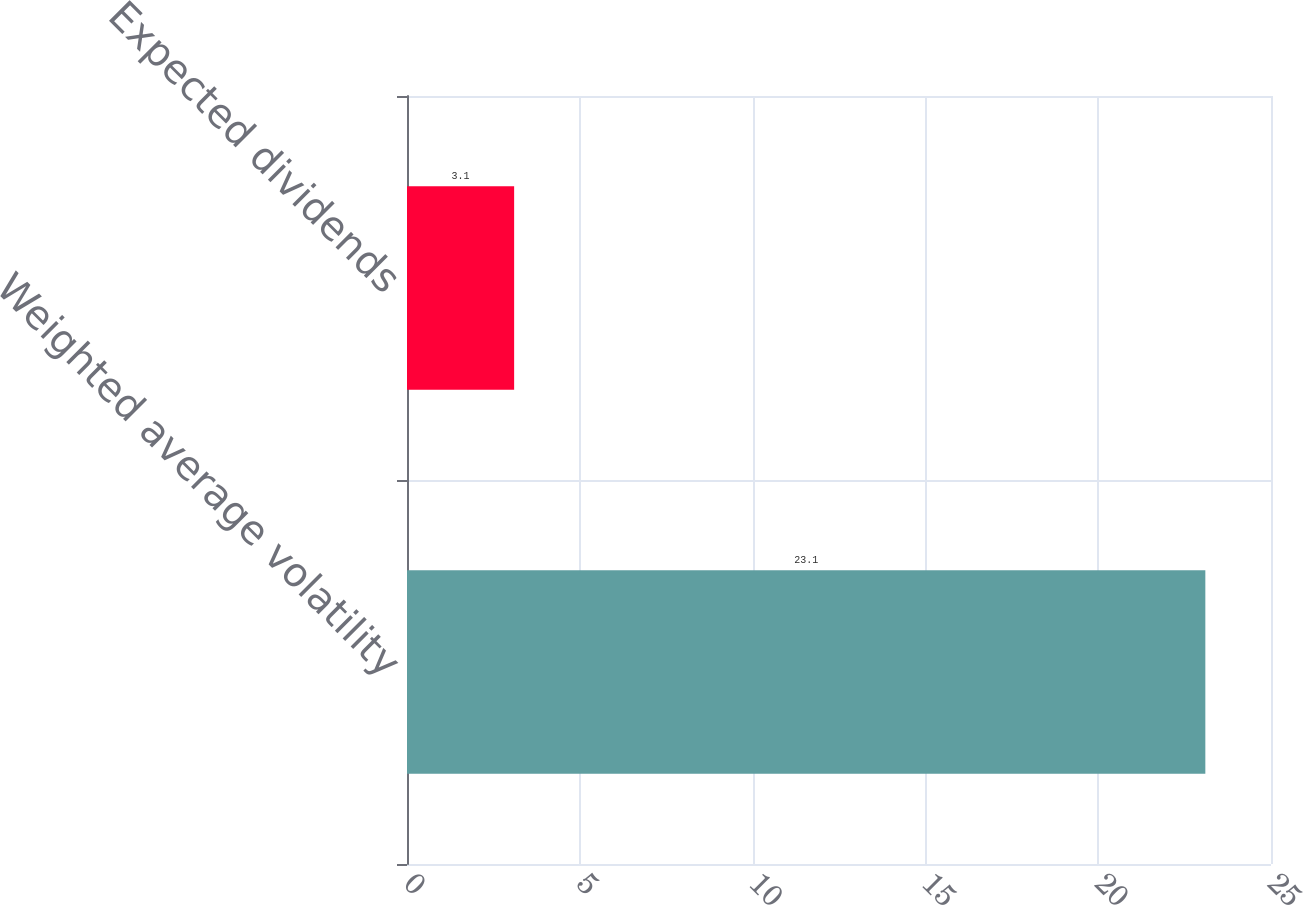Convert chart. <chart><loc_0><loc_0><loc_500><loc_500><bar_chart><fcel>Weighted average volatility<fcel>Expected dividends<nl><fcel>23.1<fcel>3.1<nl></chart> 